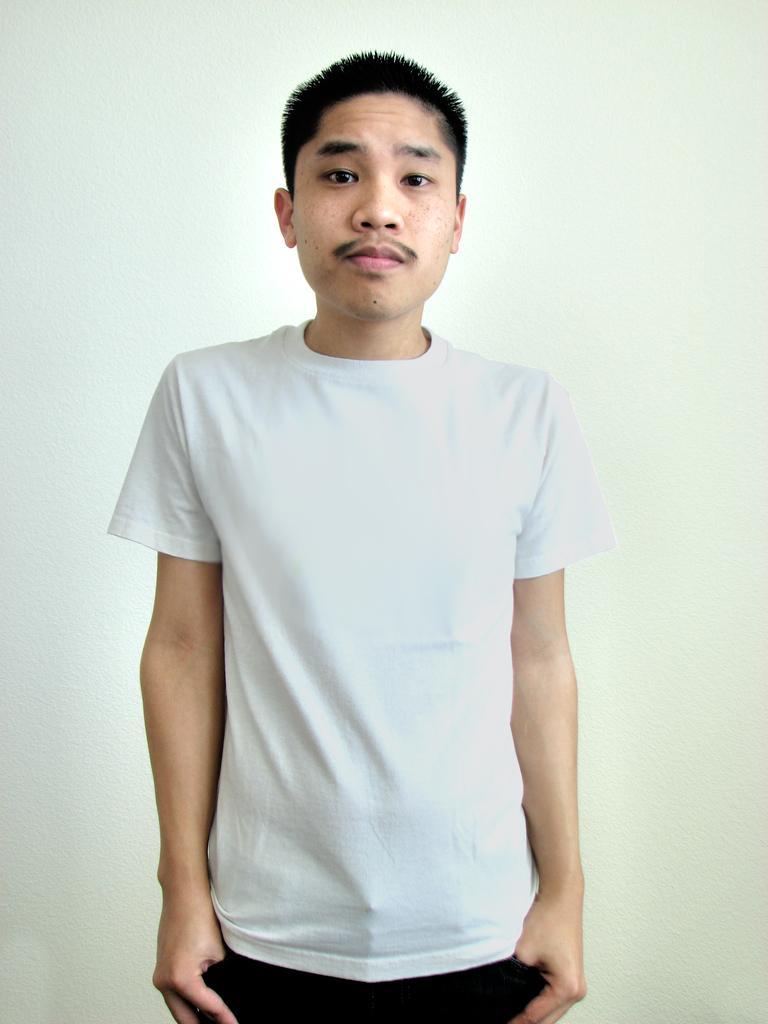Describe this image in one or two sentences. In this image we can see a person standing. 